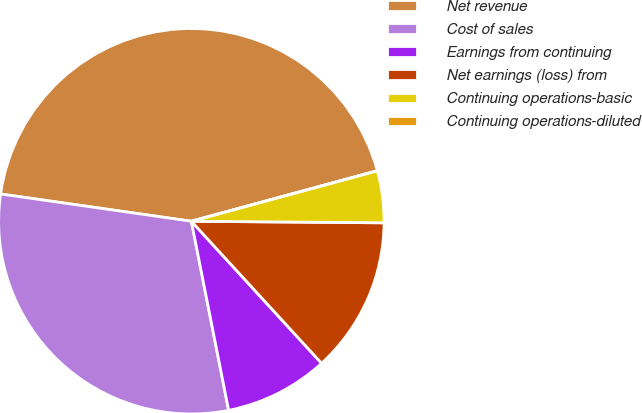<chart> <loc_0><loc_0><loc_500><loc_500><pie_chart><fcel>Net revenue<fcel>Cost of sales<fcel>Earnings from continuing<fcel>Net earnings (loss) from<fcel>Continuing operations-basic<fcel>Continuing operations-diluted<nl><fcel>43.52%<fcel>30.36%<fcel>8.71%<fcel>13.06%<fcel>4.35%<fcel>0.0%<nl></chart> 